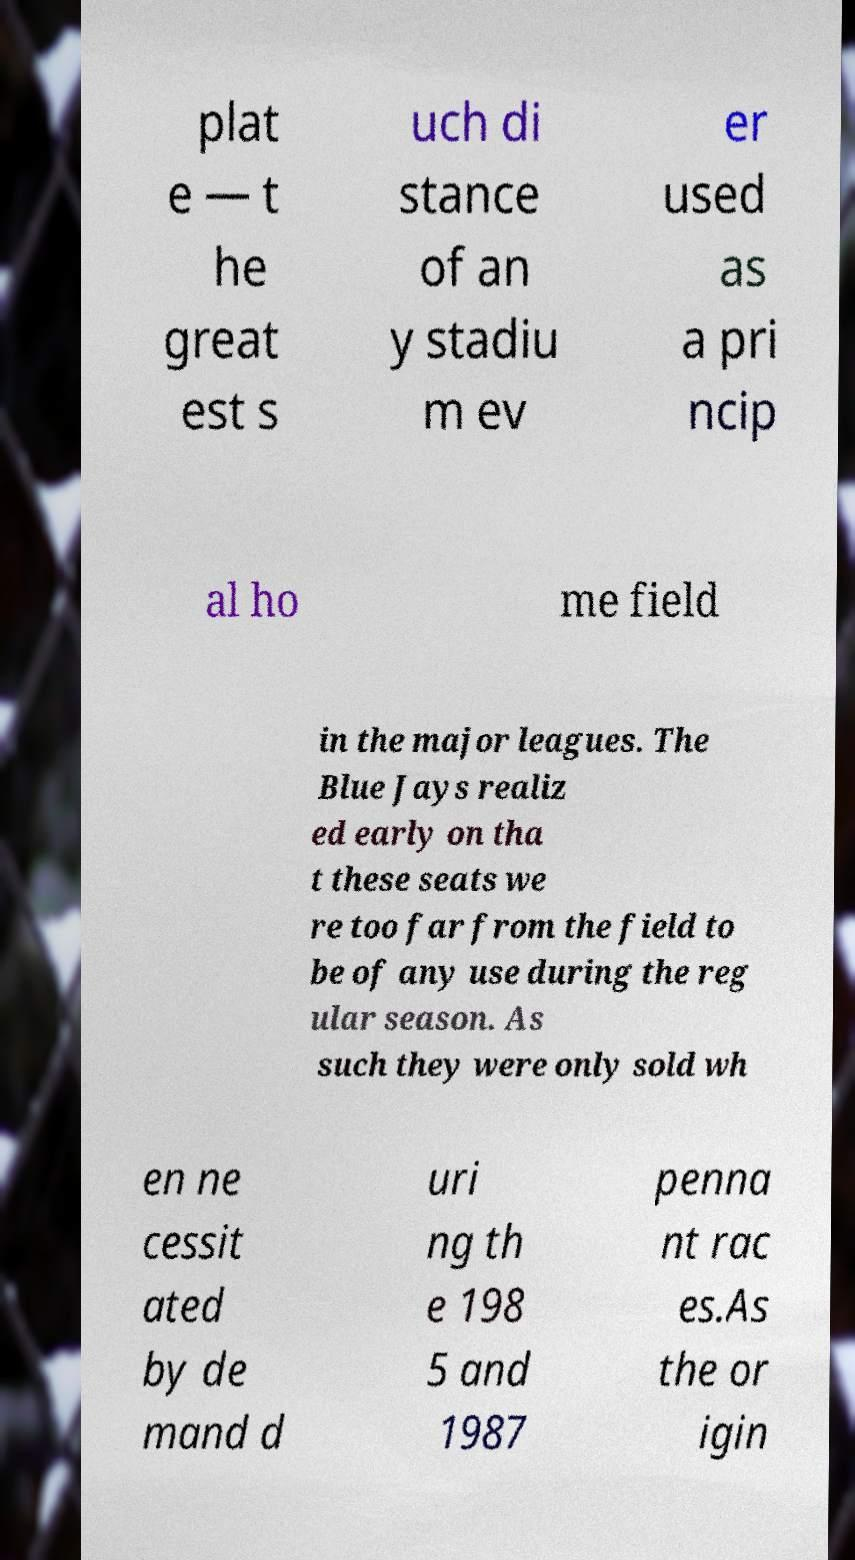Could you extract and type out the text from this image? plat e — t he great est s uch di stance of an y stadiu m ev er used as a pri ncip al ho me field in the major leagues. The Blue Jays realiz ed early on tha t these seats we re too far from the field to be of any use during the reg ular season. As such they were only sold wh en ne cessit ated by de mand d uri ng th e 198 5 and 1987 penna nt rac es.As the or igin 